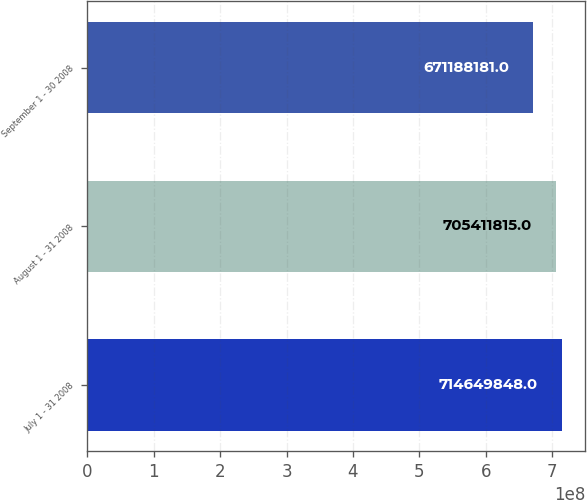Convert chart. <chart><loc_0><loc_0><loc_500><loc_500><bar_chart><fcel>July 1 - 31 2008<fcel>August 1 - 31 2008<fcel>September 1 - 30 2008<nl><fcel>7.1465e+08<fcel>7.05412e+08<fcel>6.71188e+08<nl></chart> 